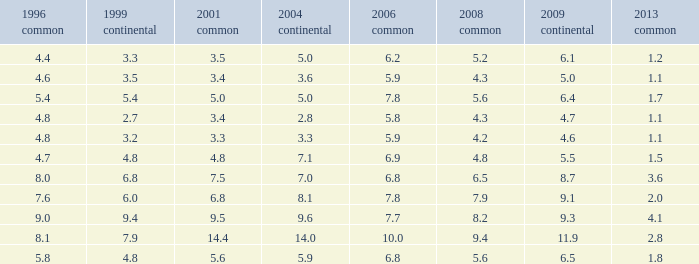What was the value for 2004 European with less than 7.5 in general 2001, less than 6.4 in 2009 European, and less than 1.5 in general 2013 with 4.3 in 2008 general? 3.6, 2.8. 